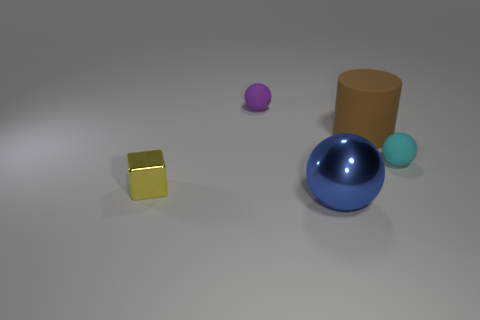What is the size of the blue object that is the same shape as the purple matte thing?
Your answer should be compact. Large. Is there anything else that is the same size as the blue metallic object?
Your answer should be compact. Yes. How many cubes are either blue metal things or brown rubber objects?
Give a very brief answer. 0. The tiny rubber sphere that is behind the big thing behind the small yellow thing is what color?
Give a very brief answer. Purple. What shape is the cyan rubber object?
Offer a very short reply. Sphere. Do the ball that is behind the matte cylinder and the large metal sphere have the same size?
Ensure brevity in your answer.  No. Are there any tiny yellow objects made of the same material as the big blue ball?
Your answer should be compact. Yes. What number of objects are either small balls on the left side of the big brown matte thing or big brown objects?
Provide a short and direct response. 2. Are there any purple shiny things?
Ensure brevity in your answer.  No. There is a tiny object that is in front of the large cylinder and to the left of the blue sphere; what is its shape?
Offer a very short reply. Cube. 